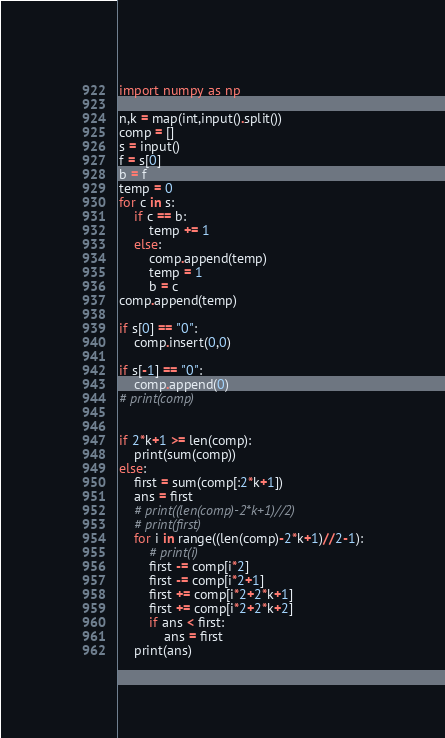<code> <loc_0><loc_0><loc_500><loc_500><_Python_>import numpy as np

n,k = map(int,input().split())
comp = []
s = input()
f = s[0]
b = f
temp = 0
for c in s:
    if c == b:
        temp += 1
    else:
        comp.append(temp)
        temp = 1
        b = c
comp.append(temp)

if s[0] == "0":
    comp.insert(0,0)

if s[-1] == "0":
    comp.append(0)
# print(comp)


if 2*k+1 >= len(comp):
    print(sum(comp))
else:
    first = sum(comp[:2*k+1])
    ans = first
    # print((len(comp)-2*k+1)//2)
    # print(first)
    for i in range((len(comp)-2*k+1)//2-1):
        # print(i)
        first -= comp[i*2]
        first -= comp[i*2+1]
        first += comp[i*2+2*k+1]
        first += comp[i*2+2*k+2]
        if ans < first:
            ans = first
    print(ans)

</code> 